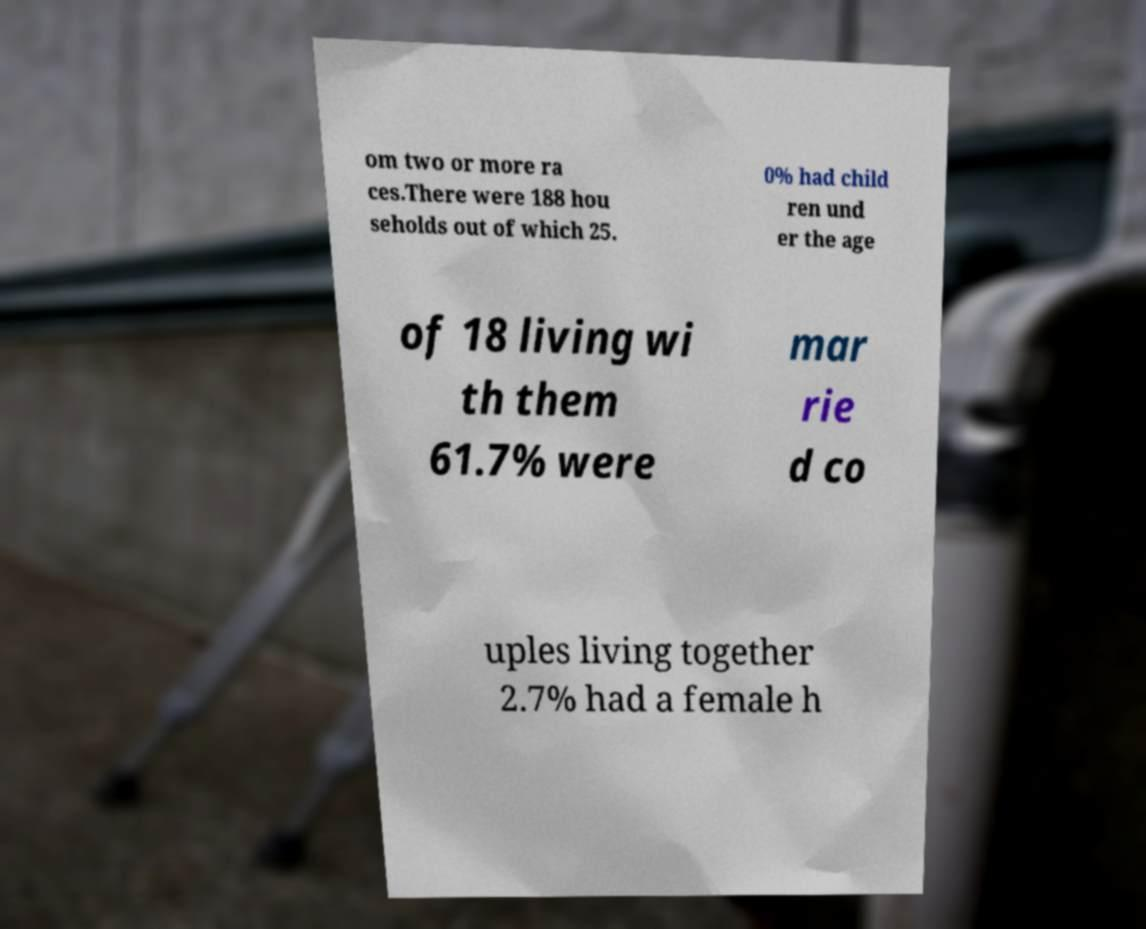What messages or text are displayed in this image? I need them in a readable, typed format. om two or more ra ces.There were 188 hou seholds out of which 25. 0% had child ren und er the age of 18 living wi th them 61.7% were mar rie d co uples living together 2.7% had a female h 